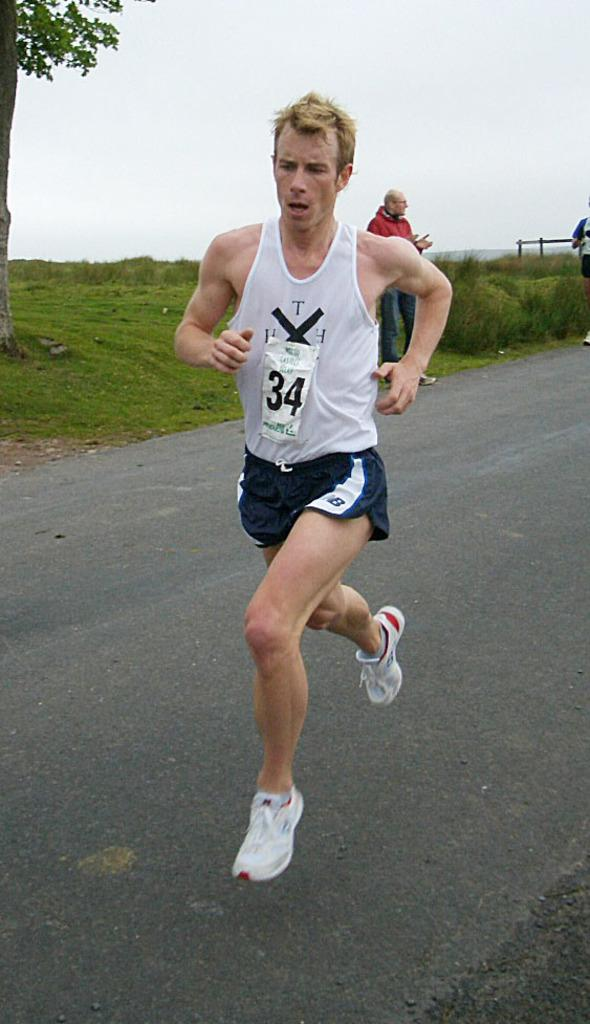<image>
Write a terse but informative summary of the picture. Runner #34 runs down the road in a pair of blue NB shorts. 